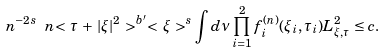<formula> <loc_0><loc_0><loc_500><loc_500>n ^ { - 2 s } \ n { < \, \tau \, + \, | \xi | ^ { 2 } \, > ^ { b ^ { \prime } } < \, \xi \, > ^ { s } \int d \nu \prod _ { i = 1 } ^ { 2 } f ^ { ( n ) } _ { i } ( \xi _ { i } , \tau _ { i } ) } { L ^ { 2 } _ { \xi , \tau } } \leq c .</formula> 